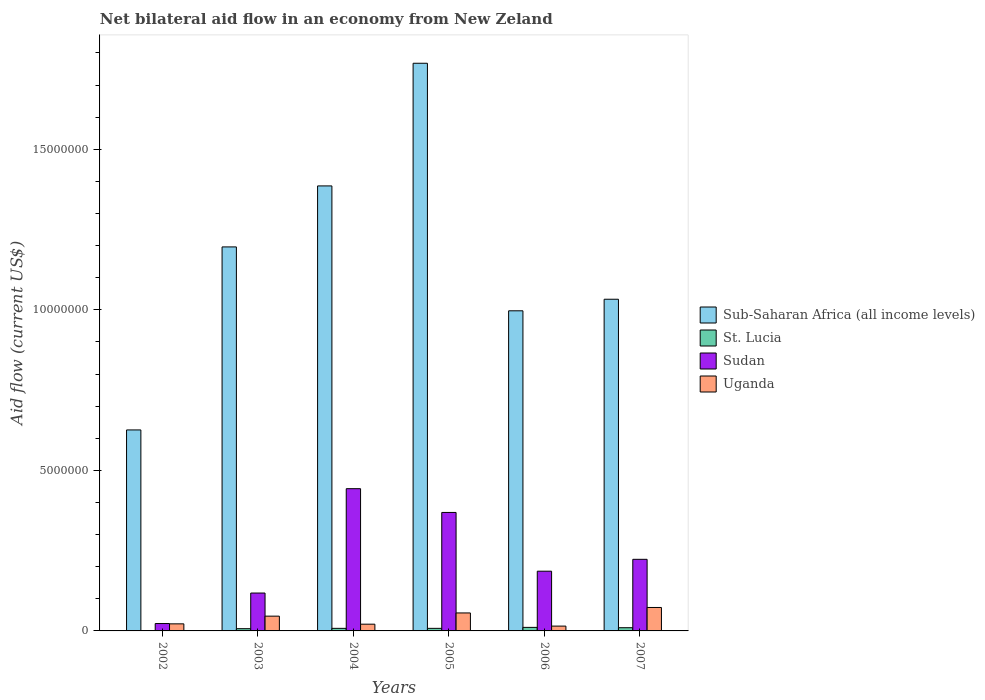How many different coloured bars are there?
Make the answer very short. 4. Are the number of bars per tick equal to the number of legend labels?
Provide a succinct answer. Yes. What is the net bilateral aid flow in Sudan in 2005?
Offer a very short reply. 3.69e+06. Across all years, what is the maximum net bilateral aid flow in Uganda?
Your answer should be compact. 7.30e+05. In which year was the net bilateral aid flow in Sub-Saharan Africa (all income levels) minimum?
Offer a very short reply. 2002. What is the total net bilateral aid flow in Sub-Saharan Africa (all income levels) in the graph?
Provide a succinct answer. 7.01e+07. What is the average net bilateral aid flow in Sudan per year?
Make the answer very short. 2.27e+06. In the year 2002, what is the difference between the net bilateral aid flow in Sub-Saharan Africa (all income levels) and net bilateral aid flow in Uganda?
Give a very brief answer. 6.04e+06. Is the difference between the net bilateral aid flow in Sub-Saharan Africa (all income levels) in 2002 and 2003 greater than the difference between the net bilateral aid flow in Uganda in 2002 and 2003?
Give a very brief answer. No. What is the difference between the highest and the second highest net bilateral aid flow in St. Lucia?
Your response must be concise. 10000. Is the sum of the net bilateral aid flow in St. Lucia in 2004 and 2006 greater than the maximum net bilateral aid flow in Sub-Saharan Africa (all income levels) across all years?
Provide a short and direct response. No. What does the 3rd bar from the left in 2005 represents?
Give a very brief answer. Sudan. What does the 4th bar from the right in 2007 represents?
Your answer should be very brief. Sub-Saharan Africa (all income levels). Is it the case that in every year, the sum of the net bilateral aid flow in Sub-Saharan Africa (all income levels) and net bilateral aid flow in Sudan is greater than the net bilateral aid flow in Uganda?
Make the answer very short. Yes. How many years are there in the graph?
Offer a terse response. 6. What is the difference between two consecutive major ticks on the Y-axis?
Provide a short and direct response. 5.00e+06. Are the values on the major ticks of Y-axis written in scientific E-notation?
Your answer should be compact. No. Where does the legend appear in the graph?
Make the answer very short. Center right. What is the title of the graph?
Keep it short and to the point. Net bilateral aid flow in an economy from New Zeland. What is the label or title of the X-axis?
Provide a succinct answer. Years. What is the label or title of the Y-axis?
Your response must be concise. Aid flow (current US$). What is the Aid flow (current US$) of Sub-Saharan Africa (all income levels) in 2002?
Offer a terse response. 6.26e+06. What is the Aid flow (current US$) in St. Lucia in 2002?
Provide a succinct answer. 10000. What is the Aid flow (current US$) of Sudan in 2002?
Offer a terse response. 2.30e+05. What is the Aid flow (current US$) of Sub-Saharan Africa (all income levels) in 2003?
Offer a very short reply. 1.20e+07. What is the Aid flow (current US$) of St. Lucia in 2003?
Give a very brief answer. 7.00e+04. What is the Aid flow (current US$) of Sudan in 2003?
Provide a short and direct response. 1.18e+06. What is the Aid flow (current US$) of Uganda in 2003?
Your answer should be compact. 4.60e+05. What is the Aid flow (current US$) in Sub-Saharan Africa (all income levels) in 2004?
Provide a succinct answer. 1.39e+07. What is the Aid flow (current US$) in St. Lucia in 2004?
Your response must be concise. 8.00e+04. What is the Aid flow (current US$) of Sudan in 2004?
Offer a very short reply. 4.43e+06. What is the Aid flow (current US$) in Uganda in 2004?
Provide a short and direct response. 2.10e+05. What is the Aid flow (current US$) in Sub-Saharan Africa (all income levels) in 2005?
Offer a very short reply. 1.77e+07. What is the Aid flow (current US$) of St. Lucia in 2005?
Offer a very short reply. 8.00e+04. What is the Aid flow (current US$) of Sudan in 2005?
Offer a very short reply. 3.69e+06. What is the Aid flow (current US$) in Uganda in 2005?
Offer a very short reply. 5.60e+05. What is the Aid flow (current US$) of Sub-Saharan Africa (all income levels) in 2006?
Ensure brevity in your answer.  9.97e+06. What is the Aid flow (current US$) of St. Lucia in 2006?
Provide a short and direct response. 1.10e+05. What is the Aid flow (current US$) in Sudan in 2006?
Ensure brevity in your answer.  1.86e+06. What is the Aid flow (current US$) in Sub-Saharan Africa (all income levels) in 2007?
Make the answer very short. 1.03e+07. What is the Aid flow (current US$) in St. Lucia in 2007?
Offer a terse response. 1.00e+05. What is the Aid flow (current US$) of Sudan in 2007?
Keep it short and to the point. 2.23e+06. What is the Aid flow (current US$) of Uganda in 2007?
Keep it short and to the point. 7.30e+05. Across all years, what is the maximum Aid flow (current US$) in Sub-Saharan Africa (all income levels)?
Your answer should be compact. 1.77e+07. Across all years, what is the maximum Aid flow (current US$) of St. Lucia?
Ensure brevity in your answer.  1.10e+05. Across all years, what is the maximum Aid flow (current US$) in Sudan?
Your answer should be very brief. 4.43e+06. Across all years, what is the maximum Aid flow (current US$) in Uganda?
Offer a very short reply. 7.30e+05. Across all years, what is the minimum Aid flow (current US$) of Sub-Saharan Africa (all income levels)?
Make the answer very short. 6.26e+06. Across all years, what is the minimum Aid flow (current US$) in St. Lucia?
Your answer should be very brief. 10000. Across all years, what is the minimum Aid flow (current US$) of Sudan?
Keep it short and to the point. 2.30e+05. What is the total Aid flow (current US$) in Sub-Saharan Africa (all income levels) in the graph?
Offer a terse response. 7.01e+07. What is the total Aid flow (current US$) of Sudan in the graph?
Ensure brevity in your answer.  1.36e+07. What is the total Aid flow (current US$) of Uganda in the graph?
Provide a short and direct response. 2.33e+06. What is the difference between the Aid flow (current US$) of Sub-Saharan Africa (all income levels) in 2002 and that in 2003?
Provide a short and direct response. -5.70e+06. What is the difference between the Aid flow (current US$) of St. Lucia in 2002 and that in 2003?
Offer a very short reply. -6.00e+04. What is the difference between the Aid flow (current US$) in Sudan in 2002 and that in 2003?
Provide a short and direct response. -9.50e+05. What is the difference between the Aid flow (current US$) of Uganda in 2002 and that in 2003?
Make the answer very short. -2.40e+05. What is the difference between the Aid flow (current US$) of Sub-Saharan Africa (all income levels) in 2002 and that in 2004?
Offer a terse response. -7.60e+06. What is the difference between the Aid flow (current US$) of St. Lucia in 2002 and that in 2004?
Ensure brevity in your answer.  -7.00e+04. What is the difference between the Aid flow (current US$) in Sudan in 2002 and that in 2004?
Make the answer very short. -4.20e+06. What is the difference between the Aid flow (current US$) of Sub-Saharan Africa (all income levels) in 2002 and that in 2005?
Ensure brevity in your answer.  -1.14e+07. What is the difference between the Aid flow (current US$) in St. Lucia in 2002 and that in 2005?
Make the answer very short. -7.00e+04. What is the difference between the Aid flow (current US$) in Sudan in 2002 and that in 2005?
Offer a very short reply. -3.46e+06. What is the difference between the Aid flow (current US$) of Sub-Saharan Africa (all income levels) in 2002 and that in 2006?
Your response must be concise. -3.71e+06. What is the difference between the Aid flow (current US$) in St. Lucia in 2002 and that in 2006?
Keep it short and to the point. -1.00e+05. What is the difference between the Aid flow (current US$) of Sudan in 2002 and that in 2006?
Your response must be concise. -1.63e+06. What is the difference between the Aid flow (current US$) of Uganda in 2002 and that in 2006?
Your answer should be compact. 7.00e+04. What is the difference between the Aid flow (current US$) in Sub-Saharan Africa (all income levels) in 2002 and that in 2007?
Ensure brevity in your answer.  -4.07e+06. What is the difference between the Aid flow (current US$) in Sudan in 2002 and that in 2007?
Keep it short and to the point. -2.00e+06. What is the difference between the Aid flow (current US$) in Uganda in 2002 and that in 2007?
Keep it short and to the point. -5.10e+05. What is the difference between the Aid flow (current US$) in Sub-Saharan Africa (all income levels) in 2003 and that in 2004?
Keep it short and to the point. -1.90e+06. What is the difference between the Aid flow (current US$) in Sudan in 2003 and that in 2004?
Give a very brief answer. -3.25e+06. What is the difference between the Aid flow (current US$) in Sub-Saharan Africa (all income levels) in 2003 and that in 2005?
Offer a terse response. -5.72e+06. What is the difference between the Aid flow (current US$) of St. Lucia in 2003 and that in 2005?
Your answer should be compact. -10000. What is the difference between the Aid flow (current US$) in Sudan in 2003 and that in 2005?
Offer a very short reply. -2.51e+06. What is the difference between the Aid flow (current US$) of Uganda in 2003 and that in 2005?
Your response must be concise. -1.00e+05. What is the difference between the Aid flow (current US$) of Sub-Saharan Africa (all income levels) in 2003 and that in 2006?
Offer a very short reply. 1.99e+06. What is the difference between the Aid flow (current US$) in Sudan in 2003 and that in 2006?
Provide a short and direct response. -6.80e+05. What is the difference between the Aid flow (current US$) in Uganda in 2003 and that in 2006?
Provide a short and direct response. 3.10e+05. What is the difference between the Aid flow (current US$) in Sub-Saharan Africa (all income levels) in 2003 and that in 2007?
Make the answer very short. 1.63e+06. What is the difference between the Aid flow (current US$) in St. Lucia in 2003 and that in 2007?
Offer a terse response. -3.00e+04. What is the difference between the Aid flow (current US$) of Sudan in 2003 and that in 2007?
Your response must be concise. -1.05e+06. What is the difference between the Aid flow (current US$) in Sub-Saharan Africa (all income levels) in 2004 and that in 2005?
Give a very brief answer. -3.82e+06. What is the difference between the Aid flow (current US$) in Sudan in 2004 and that in 2005?
Provide a short and direct response. 7.40e+05. What is the difference between the Aid flow (current US$) of Uganda in 2004 and that in 2005?
Make the answer very short. -3.50e+05. What is the difference between the Aid flow (current US$) of Sub-Saharan Africa (all income levels) in 2004 and that in 2006?
Your answer should be compact. 3.89e+06. What is the difference between the Aid flow (current US$) in Sudan in 2004 and that in 2006?
Offer a terse response. 2.57e+06. What is the difference between the Aid flow (current US$) in Sub-Saharan Africa (all income levels) in 2004 and that in 2007?
Provide a succinct answer. 3.53e+06. What is the difference between the Aid flow (current US$) of St. Lucia in 2004 and that in 2007?
Your answer should be very brief. -2.00e+04. What is the difference between the Aid flow (current US$) in Sudan in 2004 and that in 2007?
Your response must be concise. 2.20e+06. What is the difference between the Aid flow (current US$) in Uganda in 2004 and that in 2007?
Make the answer very short. -5.20e+05. What is the difference between the Aid flow (current US$) of Sub-Saharan Africa (all income levels) in 2005 and that in 2006?
Your answer should be compact. 7.71e+06. What is the difference between the Aid flow (current US$) in Sudan in 2005 and that in 2006?
Provide a short and direct response. 1.83e+06. What is the difference between the Aid flow (current US$) in Sub-Saharan Africa (all income levels) in 2005 and that in 2007?
Offer a very short reply. 7.35e+06. What is the difference between the Aid flow (current US$) of St. Lucia in 2005 and that in 2007?
Provide a short and direct response. -2.00e+04. What is the difference between the Aid flow (current US$) of Sudan in 2005 and that in 2007?
Offer a terse response. 1.46e+06. What is the difference between the Aid flow (current US$) in Uganda in 2005 and that in 2007?
Your answer should be very brief. -1.70e+05. What is the difference between the Aid flow (current US$) of Sub-Saharan Africa (all income levels) in 2006 and that in 2007?
Offer a terse response. -3.60e+05. What is the difference between the Aid flow (current US$) in St. Lucia in 2006 and that in 2007?
Provide a succinct answer. 10000. What is the difference between the Aid flow (current US$) in Sudan in 2006 and that in 2007?
Provide a succinct answer. -3.70e+05. What is the difference between the Aid flow (current US$) in Uganda in 2006 and that in 2007?
Provide a succinct answer. -5.80e+05. What is the difference between the Aid flow (current US$) in Sub-Saharan Africa (all income levels) in 2002 and the Aid flow (current US$) in St. Lucia in 2003?
Provide a succinct answer. 6.19e+06. What is the difference between the Aid flow (current US$) in Sub-Saharan Africa (all income levels) in 2002 and the Aid flow (current US$) in Sudan in 2003?
Your answer should be compact. 5.08e+06. What is the difference between the Aid flow (current US$) of Sub-Saharan Africa (all income levels) in 2002 and the Aid flow (current US$) of Uganda in 2003?
Keep it short and to the point. 5.80e+06. What is the difference between the Aid flow (current US$) in St. Lucia in 2002 and the Aid flow (current US$) in Sudan in 2003?
Keep it short and to the point. -1.17e+06. What is the difference between the Aid flow (current US$) in St. Lucia in 2002 and the Aid flow (current US$) in Uganda in 2003?
Your answer should be compact. -4.50e+05. What is the difference between the Aid flow (current US$) in Sudan in 2002 and the Aid flow (current US$) in Uganda in 2003?
Your answer should be compact. -2.30e+05. What is the difference between the Aid flow (current US$) of Sub-Saharan Africa (all income levels) in 2002 and the Aid flow (current US$) of St. Lucia in 2004?
Keep it short and to the point. 6.18e+06. What is the difference between the Aid flow (current US$) in Sub-Saharan Africa (all income levels) in 2002 and the Aid flow (current US$) in Sudan in 2004?
Your answer should be very brief. 1.83e+06. What is the difference between the Aid flow (current US$) of Sub-Saharan Africa (all income levels) in 2002 and the Aid flow (current US$) of Uganda in 2004?
Offer a very short reply. 6.05e+06. What is the difference between the Aid flow (current US$) of St. Lucia in 2002 and the Aid flow (current US$) of Sudan in 2004?
Your answer should be very brief. -4.42e+06. What is the difference between the Aid flow (current US$) of St. Lucia in 2002 and the Aid flow (current US$) of Uganda in 2004?
Make the answer very short. -2.00e+05. What is the difference between the Aid flow (current US$) of Sudan in 2002 and the Aid flow (current US$) of Uganda in 2004?
Your response must be concise. 2.00e+04. What is the difference between the Aid flow (current US$) in Sub-Saharan Africa (all income levels) in 2002 and the Aid flow (current US$) in St. Lucia in 2005?
Give a very brief answer. 6.18e+06. What is the difference between the Aid flow (current US$) in Sub-Saharan Africa (all income levels) in 2002 and the Aid flow (current US$) in Sudan in 2005?
Ensure brevity in your answer.  2.57e+06. What is the difference between the Aid flow (current US$) in Sub-Saharan Africa (all income levels) in 2002 and the Aid flow (current US$) in Uganda in 2005?
Offer a terse response. 5.70e+06. What is the difference between the Aid flow (current US$) of St. Lucia in 2002 and the Aid flow (current US$) of Sudan in 2005?
Your answer should be very brief. -3.68e+06. What is the difference between the Aid flow (current US$) of St. Lucia in 2002 and the Aid flow (current US$) of Uganda in 2005?
Provide a succinct answer. -5.50e+05. What is the difference between the Aid flow (current US$) in Sudan in 2002 and the Aid flow (current US$) in Uganda in 2005?
Offer a very short reply. -3.30e+05. What is the difference between the Aid flow (current US$) in Sub-Saharan Africa (all income levels) in 2002 and the Aid flow (current US$) in St. Lucia in 2006?
Keep it short and to the point. 6.15e+06. What is the difference between the Aid flow (current US$) of Sub-Saharan Africa (all income levels) in 2002 and the Aid flow (current US$) of Sudan in 2006?
Provide a succinct answer. 4.40e+06. What is the difference between the Aid flow (current US$) of Sub-Saharan Africa (all income levels) in 2002 and the Aid flow (current US$) of Uganda in 2006?
Make the answer very short. 6.11e+06. What is the difference between the Aid flow (current US$) in St. Lucia in 2002 and the Aid flow (current US$) in Sudan in 2006?
Keep it short and to the point. -1.85e+06. What is the difference between the Aid flow (current US$) in St. Lucia in 2002 and the Aid flow (current US$) in Uganda in 2006?
Your answer should be compact. -1.40e+05. What is the difference between the Aid flow (current US$) in Sub-Saharan Africa (all income levels) in 2002 and the Aid flow (current US$) in St. Lucia in 2007?
Offer a terse response. 6.16e+06. What is the difference between the Aid flow (current US$) of Sub-Saharan Africa (all income levels) in 2002 and the Aid flow (current US$) of Sudan in 2007?
Make the answer very short. 4.03e+06. What is the difference between the Aid flow (current US$) of Sub-Saharan Africa (all income levels) in 2002 and the Aid flow (current US$) of Uganda in 2007?
Your answer should be compact. 5.53e+06. What is the difference between the Aid flow (current US$) of St. Lucia in 2002 and the Aid flow (current US$) of Sudan in 2007?
Offer a terse response. -2.22e+06. What is the difference between the Aid flow (current US$) of St. Lucia in 2002 and the Aid flow (current US$) of Uganda in 2007?
Your answer should be very brief. -7.20e+05. What is the difference between the Aid flow (current US$) in Sudan in 2002 and the Aid flow (current US$) in Uganda in 2007?
Your response must be concise. -5.00e+05. What is the difference between the Aid flow (current US$) of Sub-Saharan Africa (all income levels) in 2003 and the Aid flow (current US$) of St. Lucia in 2004?
Offer a terse response. 1.19e+07. What is the difference between the Aid flow (current US$) of Sub-Saharan Africa (all income levels) in 2003 and the Aid flow (current US$) of Sudan in 2004?
Offer a terse response. 7.53e+06. What is the difference between the Aid flow (current US$) of Sub-Saharan Africa (all income levels) in 2003 and the Aid flow (current US$) of Uganda in 2004?
Keep it short and to the point. 1.18e+07. What is the difference between the Aid flow (current US$) of St. Lucia in 2003 and the Aid flow (current US$) of Sudan in 2004?
Offer a terse response. -4.36e+06. What is the difference between the Aid flow (current US$) in St. Lucia in 2003 and the Aid flow (current US$) in Uganda in 2004?
Make the answer very short. -1.40e+05. What is the difference between the Aid flow (current US$) of Sudan in 2003 and the Aid flow (current US$) of Uganda in 2004?
Ensure brevity in your answer.  9.70e+05. What is the difference between the Aid flow (current US$) in Sub-Saharan Africa (all income levels) in 2003 and the Aid flow (current US$) in St. Lucia in 2005?
Provide a short and direct response. 1.19e+07. What is the difference between the Aid flow (current US$) in Sub-Saharan Africa (all income levels) in 2003 and the Aid flow (current US$) in Sudan in 2005?
Make the answer very short. 8.27e+06. What is the difference between the Aid flow (current US$) in Sub-Saharan Africa (all income levels) in 2003 and the Aid flow (current US$) in Uganda in 2005?
Offer a terse response. 1.14e+07. What is the difference between the Aid flow (current US$) of St. Lucia in 2003 and the Aid flow (current US$) of Sudan in 2005?
Offer a terse response. -3.62e+06. What is the difference between the Aid flow (current US$) of St. Lucia in 2003 and the Aid flow (current US$) of Uganda in 2005?
Give a very brief answer. -4.90e+05. What is the difference between the Aid flow (current US$) of Sudan in 2003 and the Aid flow (current US$) of Uganda in 2005?
Your response must be concise. 6.20e+05. What is the difference between the Aid flow (current US$) of Sub-Saharan Africa (all income levels) in 2003 and the Aid flow (current US$) of St. Lucia in 2006?
Ensure brevity in your answer.  1.18e+07. What is the difference between the Aid flow (current US$) of Sub-Saharan Africa (all income levels) in 2003 and the Aid flow (current US$) of Sudan in 2006?
Ensure brevity in your answer.  1.01e+07. What is the difference between the Aid flow (current US$) in Sub-Saharan Africa (all income levels) in 2003 and the Aid flow (current US$) in Uganda in 2006?
Keep it short and to the point. 1.18e+07. What is the difference between the Aid flow (current US$) of St. Lucia in 2003 and the Aid flow (current US$) of Sudan in 2006?
Ensure brevity in your answer.  -1.79e+06. What is the difference between the Aid flow (current US$) in Sudan in 2003 and the Aid flow (current US$) in Uganda in 2006?
Your answer should be compact. 1.03e+06. What is the difference between the Aid flow (current US$) of Sub-Saharan Africa (all income levels) in 2003 and the Aid flow (current US$) of St. Lucia in 2007?
Make the answer very short. 1.19e+07. What is the difference between the Aid flow (current US$) of Sub-Saharan Africa (all income levels) in 2003 and the Aid flow (current US$) of Sudan in 2007?
Offer a very short reply. 9.73e+06. What is the difference between the Aid flow (current US$) of Sub-Saharan Africa (all income levels) in 2003 and the Aid flow (current US$) of Uganda in 2007?
Offer a terse response. 1.12e+07. What is the difference between the Aid flow (current US$) in St. Lucia in 2003 and the Aid flow (current US$) in Sudan in 2007?
Provide a short and direct response. -2.16e+06. What is the difference between the Aid flow (current US$) of St. Lucia in 2003 and the Aid flow (current US$) of Uganda in 2007?
Your answer should be very brief. -6.60e+05. What is the difference between the Aid flow (current US$) in Sudan in 2003 and the Aid flow (current US$) in Uganda in 2007?
Your answer should be compact. 4.50e+05. What is the difference between the Aid flow (current US$) of Sub-Saharan Africa (all income levels) in 2004 and the Aid flow (current US$) of St. Lucia in 2005?
Ensure brevity in your answer.  1.38e+07. What is the difference between the Aid flow (current US$) of Sub-Saharan Africa (all income levels) in 2004 and the Aid flow (current US$) of Sudan in 2005?
Provide a succinct answer. 1.02e+07. What is the difference between the Aid flow (current US$) in Sub-Saharan Africa (all income levels) in 2004 and the Aid flow (current US$) in Uganda in 2005?
Your answer should be compact. 1.33e+07. What is the difference between the Aid flow (current US$) of St. Lucia in 2004 and the Aid flow (current US$) of Sudan in 2005?
Offer a very short reply. -3.61e+06. What is the difference between the Aid flow (current US$) in St. Lucia in 2004 and the Aid flow (current US$) in Uganda in 2005?
Provide a short and direct response. -4.80e+05. What is the difference between the Aid flow (current US$) of Sudan in 2004 and the Aid flow (current US$) of Uganda in 2005?
Provide a succinct answer. 3.87e+06. What is the difference between the Aid flow (current US$) in Sub-Saharan Africa (all income levels) in 2004 and the Aid flow (current US$) in St. Lucia in 2006?
Provide a short and direct response. 1.38e+07. What is the difference between the Aid flow (current US$) of Sub-Saharan Africa (all income levels) in 2004 and the Aid flow (current US$) of Uganda in 2006?
Your response must be concise. 1.37e+07. What is the difference between the Aid flow (current US$) in St. Lucia in 2004 and the Aid flow (current US$) in Sudan in 2006?
Keep it short and to the point. -1.78e+06. What is the difference between the Aid flow (current US$) of Sudan in 2004 and the Aid flow (current US$) of Uganda in 2006?
Ensure brevity in your answer.  4.28e+06. What is the difference between the Aid flow (current US$) in Sub-Saharan Africa (all income levels) in 2004 and the Aid flow (current US$) in St. Lucia in 2007?
Provide a succinct answer. 1.38e+07. What is the difference between the Aid flow (current US$) of Sub-Saharan Africa (all income levels) in 2004 and the Aid flow (current US$) of Sudan in 2007?
Your answer should be very brief. 1.16e+07. What is the difference between the Aid flow (current US$) of Sub-Saharan Africa (all income levels) in 2004 and the Aid flow (current US$) of Uganda in 2007?
Your answer should be very brief. 1.31e+07. What is the difference between the Aid flow (current US$) in St. Lucia in 2004 and the Aid flow (current US$) in Sudan in 2007?
Provide a succinct answer. -2.15e+06. What is the difference between the Aid flow (current US$) of St. Lucia in 2004 and the Aid flow (current US$) of Uganda in 2007?
Provide a succinct answer. -6.50e+05. What is the difference between the Aid flow (current US$) of Sudan in 2004 and the Aid flow (current US$) of Uganda in 2007?
Make the answer very short. 3.70e+06. What is the difference between the Aid flow (current US$) in Sub-Saharan Africa (all income levels) in 2005 and the Aid flow (current US$) in St. Lucia in 2006?
Offer a very short reply. 1.76e+07. What is the difference between the Aid flow (current US$) of Sub-Saharan Africa (all income levels) in 2005 and the Aid flow (current US$) of Sudan in 2006?
Your answer should be very brief. 1.58e+07. What is the difference between the Aid flow (current US$) in Sub-Saharan Africa (all income levels) in 2005 and the Aid flow (current US$) in Uganda in 2006?
Provide a succinct answer. 1.75e+07. What is the difference between the Aid flow (current US$) in St. Lucia in 2005 and the Aid flow (current US$) in Sudan in 2006?
Your answer should be very brief. -1.78e+06. What is the difference between the Aid flow (current US$) in St. Lucia in 2005 and the Aid flow (current US$) in Uganda in 2006?
Your answer should be compact. -7.00e+04. What is the difference between the Aid flow (current US$) in Sudan in 2005 and the Aid flow (current US$) in Uganda in 2006?
Provide a short and direct response. 3.54e+06. What is the difference between the Aid flow (current US$) in Sub-Saharan Africa (all income levels) in 2005 and the Aid flow (current US$) in St. Lucia in 2007?
Your answer should be compact. 1.76e+07. What is the difference between the Aid flow (current US$) of Sub-Saharan Africa (all income levels) in 2005 and the Aid flow (current US$) of Sudan in 2007?
Your response must be concise. 1.54e+07. What is the difference between the Aid flow (current US$) of Sub-Saharan Africa (all income levels) in 2005 and the Aid flow (current US$) of Uganda in 2007?
Provide a short and direct response. 1.70e+07. What is the difference between the Aid flow (current US$) in St. Lucia in 2005 and the Aid flow (current US$) in Sudan in 2007?
Ensure brevity in your answer.  -2.15e+06. What is the difference between the Aid flow (current US$) in St. Lucia in 2005 and the Aid flow (current US$) in Uganda in 2007?
Give a very brief answer. -6.50e+05. What is the difference between the Aid flow (current US$) in Sudan in 2005 and the Aid flow (current US$) in Uganda in 2007?
Your answer should be compact. 2.96e+06. What is the difference between the Aid flow (current US$) of Sub-Saharan Africa (all income levels) in 2006 and the Aid flow (current US$) of St. Lucia in 2007?
Keep it short and to the point. 9.87e+06. What is the difference between the Aid flow (current US$) of Sub-Saharan Africa (all income levels) in 2006 and the Aid flow (current US$) of Sudan in 2007?
Offer a terse response. 7.74e+06. What is the difference between the Aid flow (current US$) of Sub-Saharan Africa (all income levels) in 2006 and the Aid flow (current US$) of Uganda in 2007?
Offer a very short reply. 9.24e+06. What is the difference between the Aid flow (current US$) of St. Lucia in 2006 and the Aid flow (current US$) of Sudan in 2007?
Your answer should be very brief. -2.12e+06. What is the difference between the Aid flow (current US$) in St. Lucia in 2006 and the Aid flow (current US$) in Uganda in 2007?
Offer a very short reply. -6.20e+05. What is the difference between the Aid flow (current US$) in Sudan in 2006 and the Aid flow (current US$) in Uganda in 2007?
Provide a short and direct response. 1.13e+06. What is the average Aid flow (current US$) of Sub-Saharan Africa (all income levels) per year?
Offer a terse response. 1.17e+07. What is the average Aid flow (current US$) in St. Lucia per year?
Make the answer very short. 7.50e+04. What is the average Aid flow (current US$) in Sudan per year?
Your answer should be very brief. 2.27e+06. What is the average Aid flow (current US$) of Uganda per year?
Give a very brief answer. 3.88e+05. In the year 2002, what is the difference between the Aid flow (current US$) in Sub-Saharan Africa (all income levels) and Aid flow (current US$) in St. Lucia?
Give a very brief answer. 6.25e+06. In the year 2002, what is the difference between the Aid flow (current US$) of Sub-Saharan Africa (all income levels) and Aid flow (current US$) of Sudan?
Offer a terse response. 6.03e+06. In the year 2002, what is the difference between the Aid flow (current US$) in Sub-Saharan Africa (all income levels) and Aid flow (current US$) in Uganda?
Give a very brief answer. 6.04e+06. In the year 2002, what is the difference between the Aid flow (current US$) of St. Lucia and Aid flow (current US$) of Uganda?
Your response must be concise. -2.10e+05. In the year 2003, what is the difference between the Aid flow (current US$) in Sub-Saharan Africa (all income levels) and Aid flow (current US$) in St. Lucia?
Ensure brevity in your answer.  1.19e+07. In the year 2003, what is the difference between the Aid flow (current US$) of Sub-Saharan Africa (all income levels) and Aid flow (current US$) of Sudan?
Your answer should be very brief. 1.08e+07. In the year 2003, what is the difference between the Aid flow (current US$) in Sub-Saharan Africa (all income levels) and Aid flow (current US$) in Uganda?
Provide a succinct answer. 1.15e+07. In the year 2003, what is the difference between the Aid flow (current US$) in St. Lucia and Aid flow (current US$) in Sudan?
Provide a succinct answer. -1.11e+06. In the year 2003, what is the difference between the Aid flow (current US$) of St. Lucia and Aid flow (current US$) of Uganda?
Your answer should be very brief. -3.90e+05. In the year 2003, what is the difference between the Aid flow (current US$) in Sudan and Aid flow (current US$) in Uganda?
Give a very brief answer. 7.20e+05. In the year 2004, what is the difference between the Aid flow (current US$) in Sub-Saharan Africa (all income levels) and Aid flow (current US$) in St. Lucia?
Offer a very short reply. 1.38e+07. In the year 2004, what is the difference between the Aid flow (current US$) of Sub-Saharan Africa (all income levels) and Aid flow (current US$) of Sudan?
Offer a terse response. 9.43e+06. In the year 2004, what is the difference between the Aid flow (current US$) of Sub-Saharan Africa (all income levels) and Aid flow (current US$) of Uganda?
Provide a succinct answer. 1.36e+07. In the year 2004, what is the difference between the Aid flow (current US$) in St. Lucia and Aid flow (current US$) in Sudan?
Make the answer very short. -4.35e+06. In the year 2004, what is the difference between the Aid flow (current US$) of Sudan and Aid flow (current US$) of Uganda?
Keep it short and to the point. 4.22e+06. In the year 2005, what is the difference between the Aid flow (current US$) of Sub-Saharan Africa (all income levels) and Aid flow (current US$) of St. Lucia?
Offer a terse response. 1.76e+07. In the year 2005, what is the difference between the Aid flow (current US$) of Sub-Saharan Africa (all income levels) and Aid flow (current US$) of Sudan?
Offer a terse response. 1.40e+07. In the year 2005, what is the difference between the Aid flow (current US$) in Sub-Saharan Africa (all income levels) and Aid flow (current US$) in Uganda?
Your answer should be very brief. 1.71e+07. In the year 2005, what is the difference between the Aid flow (current US$) of St. Lucia and Aid flow (current US$) of Sudan?
Offer a very short reply. -3.61e+06. In the year 2005, what is the difference between the Aid flow (current US$) of St. Lucia and Aid flow (current US$) of Uganda?
Keep it short and to the point. -4.80e+05. In the year 2005, what is the difference between the Aid flow (current US$) in Sudan and Aid flow (current US$) in Uganda?
Your response must be concise. 3.13e+06. In the year 2006, what is the difference between the Aid flow (current US$) in Sub-Saharan Africa (all income levels) and Aid flow (current US$) in St. Lucia?
Ensure brevity in your answer.  9.86e+06. In the year 2006, what is the difference between the Aid flow (current US$) of Sub-Saharan Africa (all income levels) and Aid flow (current US$) of Sudan?
Keep it short and to the point. 8.11e+06. In the year 2006, what is the difference between the Aid flow (current US$) of Sub-Saharan Africa (all income levels) and Aid flow (current US$) of Uganda?
Give a very brief answer. 9.82e+06. In the year 2006, what is the difference between the Aid flow (current US$) in St. Lucia and Aid flow (current US$) in Sudan?
Keep it short and to the point. -1.75e+06. In the year 2006, what is the difference between the Aid flow (current US$) of Sudan and Aid flow (current US$) of Uganda?
Your answer should be very brief. 1.71e+06. In the year 2007, what is the difference between the Aid flow (current US$) of Sub-Saharan Africa (all income levels) and Aid flow (current US$) of St. Lucia?
Ensure brevity in your answer.  1.02e+07. In the year 2007, what is the difference between the Aid flow (current US$) in Sub-Saharan Africa (all income levels) and Aid flow (current US$) in Sudan?
Provide a succinct answer. 8.10e+06. In the year 2007, what is the difference between the Aid flow (current US$) in Sub-Saharan Africa (all income levels) and Aid flow (current US$) in Uganda?
Provide a short and direct response. 9.60e+06. In the year 2007, what is the difference between the Aid flow (current US$) in St. Lucia and Aid flow (current US$) in Sudan?
Your answer should be compact. -2.13e+06. In the year 2007, what is the difference between the Aid flow (current US$) in St. Lucia and Aid flow (current US$) in Uganda?
Keep it short and to the point. -6.30e+05. In the year 2007, what is the difference between the Aid flow (current US$) of Sudan and Aid flow (current US$) of Uganda?
Your answer should be compact. 1.50e+06. What is the ratio of the Aid flow (current US$) in Sub-Saharan Africa (all income levels) in 2002 to that in 2003?
Give a very brief answer. 0.52. What is the ratio of the Aid flow (current US$) in St. Lucia in 2002 to that in 2003?
Give a very brief answer. 0.14. What is the ratio of the Aid flow (current US$) of Sudan in 2002 to that in 2003?
Give a very brief answer. 0.19. What is the ratio of the Aid flow (current US$) in Uganda in 2002 to that in 2003?
Keep it short and to the point. 0.48. What is the ratio of the Aid flow (current US$) of Sub-Saharan Africa (all income levels) in 2002 to that in 2004?
Make the answer very short. 0.45. What is the ratio of the Aid flow (current US$) of Sudan in 2002 to that in 2004?
Offer a very short reply. 0.05. What is the ratio of the Aid flow (current US$) in Uganda in 2002 to that in 2004?
Your answer should be compact. 1.05. What is the ratio of the Aid flow (current US$) in Sub-Saharan Africa (all income levels) in 2002 to that in 2005?
Offer a terse response. 0.35. What is the ratio of the Aid flow (current US$) in Sudan in 2002 to that in 2005?
Make the answer very short. 0.06. What is the ratio of the Aid flow (current US$) of Uganda in 2002 to that in 2005?
Provide a succinct answer. 0.39. What is the ratio of the Aid flow (current US$) in Sub-Saharan Africa (all income levels) in 2002 to that in 2006?
Give a very brief answer. 0.63. What is the ratio of the Aid flow (current US$) in St. Lucia in 2002 to that in 2006?
Offer a very short reply. 0.09. What is the ratio of the Aid flow (current US$) of Sudan in 2002 to that in 2006?
Your response must be concise. 0.12. What is the ratio of the Aid flow (current US$) in Uganda in 2002 to that in 2006?
Your response must be concise. 1.47. What is the ratio of the Aid flow (current US$) in Sub-Saharan Africa (all income levels) in 2002 to that in 2007?
Provide a short and direct response. 0.61. What is the ratio of the Aid flow (current US$) in Sudan in 2002 to that in 2007?
Give a very brief answer. 0.1. What is the ratio of the Aid flow (current US$) of Uganda in 2002 to that in 2007?
Provide a succinct answer. 0.3. What is the ratio of the Aid flow (current US$) of Sub-Saharan Africa (all income levels) in 2003 to that in 2004?
Provide a succinct answer. 0.86. What is the ratio of the Aid flow (current US$) in Sudan in 2003 to that in 2004?
Provide a short and direct response. 0.27. What is the ratio of the Aid flow (current US$) in Uganda in 2003 to that in 2004?
Your response must be concise. 2.19. What is the ratio of the Aid flow (current US$) of Sub-Saharan Africa (all income levels) in 2003 to that in 2005?
Keep it short and to the point. 0.68. What is the ratio of the Aid flow (current US$) of Sudan in 2003 to that in 2005?
Make the answer very short. 0.32. What is the ratio of the Aid flow (current US$) in Uganda in 2003 to that in 2005?
Your answer should be very brief. 0.82. What is the ratio of the Aid flow (current US$) of Sub-Saharan Africa (all income levels) in 2003 to that in 2006?
Keep it short and to the point. 1.2. What is the ratio of the Aid flow (current US$) in St. Lucia in 2003 to that in 2006?
Your answer should be very brief. 0.64. What is the ratio of the Aid flow (current US$) in Sudan in 2003 to that in 2006?
Offer a very short reply. 0.63. What is the ratio of the Aid flow (current US$) of Uganda in 2003 to that in 2006?
Offer a very short reply. 3.07. What is the ratio of the Aid flow (current US$) in Sub-Saharan Africa (all income levels) in 2003 to that in 2007?
Provide a succinct answer. 1.16. What is the ratio of the Aid flow (current US$) in Sudan in 2003 to that in 2007?
Offer a terse response. 0.53. What is the ratio of the Aid flow (current US$) in Uganda in 2003 to that in 2007?
Provide a succinct answer. 0.63. What is the ratio of the Aid flow (current US$) in Sub-Saharan Africa (all income levels) in 2004 to that in 2005?
Your answer should be very brief. 0.78. What is the ratio of the Aid flow (current US$) of St. Lucia in 2004 to that in 2005?
Your response must be concise. 1. What is the ratio of the Aid flow (current US$) in Sudan in 2004 to that in 2005?
Make the answer very short. 1.2. What is the ratio of the Aid flow (current US$) in Sub-Saharan Africa (all income levels) in 2004 to that in 2006?
Provide a short and direct response. 1.39. What is the ratio of the Aid flow (current US$) of St. Lucia in 2004 to that in 2006?
Provide a succinct answer. 0.73. What is the ratio of the Aid flow (current US$) of Sudan in 2004 to that in 2006?
Provide a succinct answer. 2.38. What is the ratio of the Aid flow (current US$) of Uganda in 2004 to that in 2006?
Your response must be concise. 1.4. What is the ratio of the Aid flow (current US$) in Sub-Saharan Africa (all income levels) in 2004 to that in 2007?
Your response must be concise. 1.34. What is the ratio of the Aid flow (current US$) of St. Lucia in 2004 to that in 2007?
Ensure brevity in your answer.  0.8. What is the ratio of the Aid flow (current US$) of Sudan in 2004 to that in 2007?
Keep it short and to the point. 1.99. What is the ratio of the Aid flow (current US$) in Uganda in 2004 to that in 2007?
Give a very brief answer. 0.29. What is the ratio of the Aid flow (current US$) of Sub-Saharan Africa (all income levels) in 2005 to that in 2006?
Your answer should be compact. 1.77. What is the ratio of the Aid flow (current US$) in St. Lucia in 2005 to that in 2006?
Provide a succinct answer. 0.73. What is the ratio of the Aid flow (current US$) of Sudan in 2005 to that in 2006?
Provide a short and direct response. 1.98. What is the ratio of the Aid flow (current US$) of Uganda in 2005 to that in 2006?
Ensure brevity in your answer.  3.73. What is the ratio of the Aid flow (current US$) in Sub-Saharan Africa (all income levels) in 2005 to that in 2007?
Offer a terse response. 1.71. What is the ratio of the Aid flow (current US$) in St. Lucia in 2005 to that in 2007?
Provide a short and direct response. 0.8. What is the ratio of the Aid flow (current US$) in Sudan in 2005 to that in 2007?
Provide a succinct answer. 1.65. What is the ratio of the Aid flow (current US$) in Uganda in 2005 to that in 2007?
Give a very brief answer. 0.77. What is the ratio of the Aid flow (current US$) in Sub-Saharan Africa (all income levels) in 2006 to that in 2007?
Offer a terse response. 0.97. What is the ratio of the Aid flow (current US$) of St. Lucia in 2006 to that in 2007?
Offer a very short reply. 1.1. What is the ratio of the Aid flow (current US$) of Sudan in 2006 to that in 2007?
Make the answer very short. 0.83. What is the ratio of the Aid flow (current US$) in Uganda in 2006 to that in 2007?
Your answer should be compact. 0.21. What is the difference between the highest and the second highest Aid flow (current US$) of Sub-Saharan Africa (all income levels)?
Ensure brevity in your answer.  3.82e+06. What is the difference between the highest and the second highest Aid flow (current US$) of St. Lucia?
Make the answer very short. 10000. What is the difference between the highest and the second highest Aid flow (current US$) in Sudan?
Your response must be concise. 7.40e+05. What is the difference between the highest and the lowest Aid flow (current US$) in Sub-Saharan Africa (all income levels)?
Provide a short and direct response. 1.14e+07. What is the difference between the highest and the lowest Aid flow (current US$) in Sudan?
Your answer should be very brief. 4.20e+06. What is the difference between the highest and the lowest Aid flow (current US$) in Uganda?
Provide a short and direct response. 5.80e+05. 